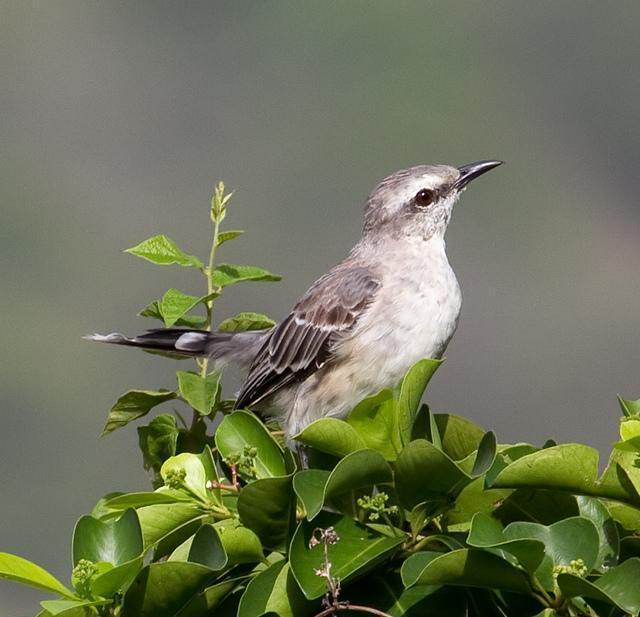How many people are shown?
Give a very brief answer. 0. 